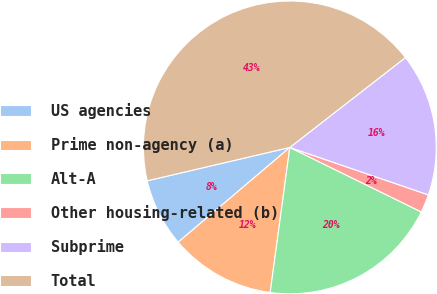<chart> <loc_0><loc_0><loc_500><loc_500><pie_chart><fcel>US agencies<fcel>Prime non-agency (a)<fcel>Alt-A<fcel>Other housing-related (b)<fcel>Subprime<fcel>Total<nl><fcel>7.54%<fcel>11.66%<fcel>19.88%<fcel>2.01%<fcel>15.77%<fcel>43.14%<nl></chart> 